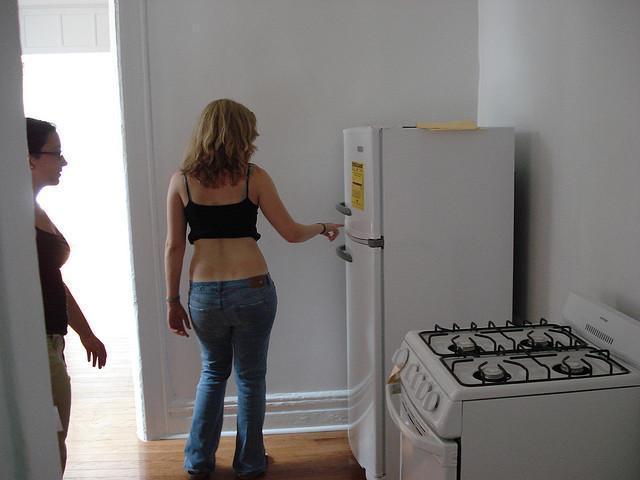How many women are there?
Give a very brief answer. 2. How many people are there?
Give a very brief answer. 2. 